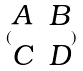Convert formula to latex. <formula><loc_0><loc_0><loc_500><loc_500>( \begin{matrix} A & B \\ C & D \end{matrix} )</formula> 